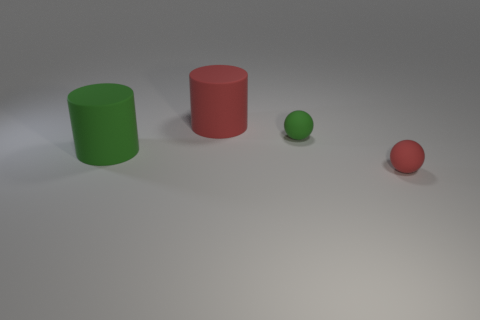Add 1 big red cylinders. How many objects exist? 5 Add 2 purple rubber cylinders. How many purple rubber cylinders exist? 2 Subtract 0 gray balls. How many objects are left? 4 Subtract all green metallic balls. Subtract all small green rubber objects. How many objects are left? 3 Add 2 small things. How many small things are left? 4 